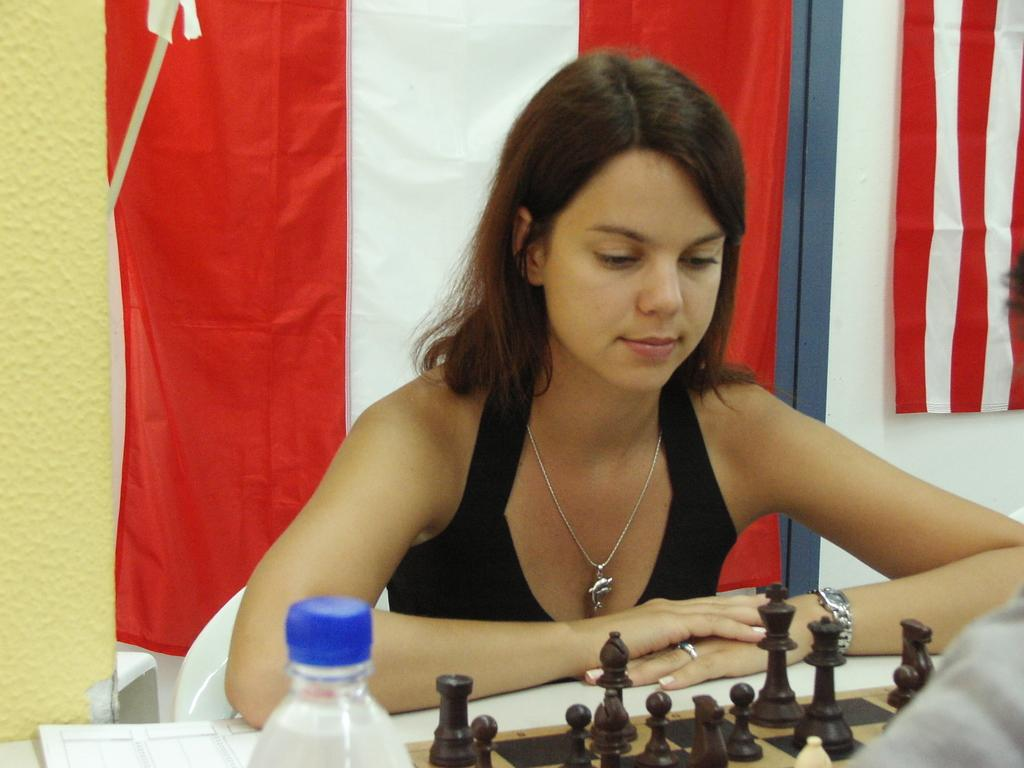Who is present in the image? There is a woman in the image. What is the woman wearing? The woman is wearing a black dress. Where is the woman located in the image? The woman is sitting behind a table. What objects are on the table? There is a bottle and a chessboard on the table. What can be seen in the background of the image? There is a flag visible in the background. What type of punishment is being administered in the image? There is no punishment being administered in the image; it features a woman sitting behind a table with a bottle and chessboard. What type of church is visible in the background of the image? There is no church visible in the background of the image; it features a flag. 